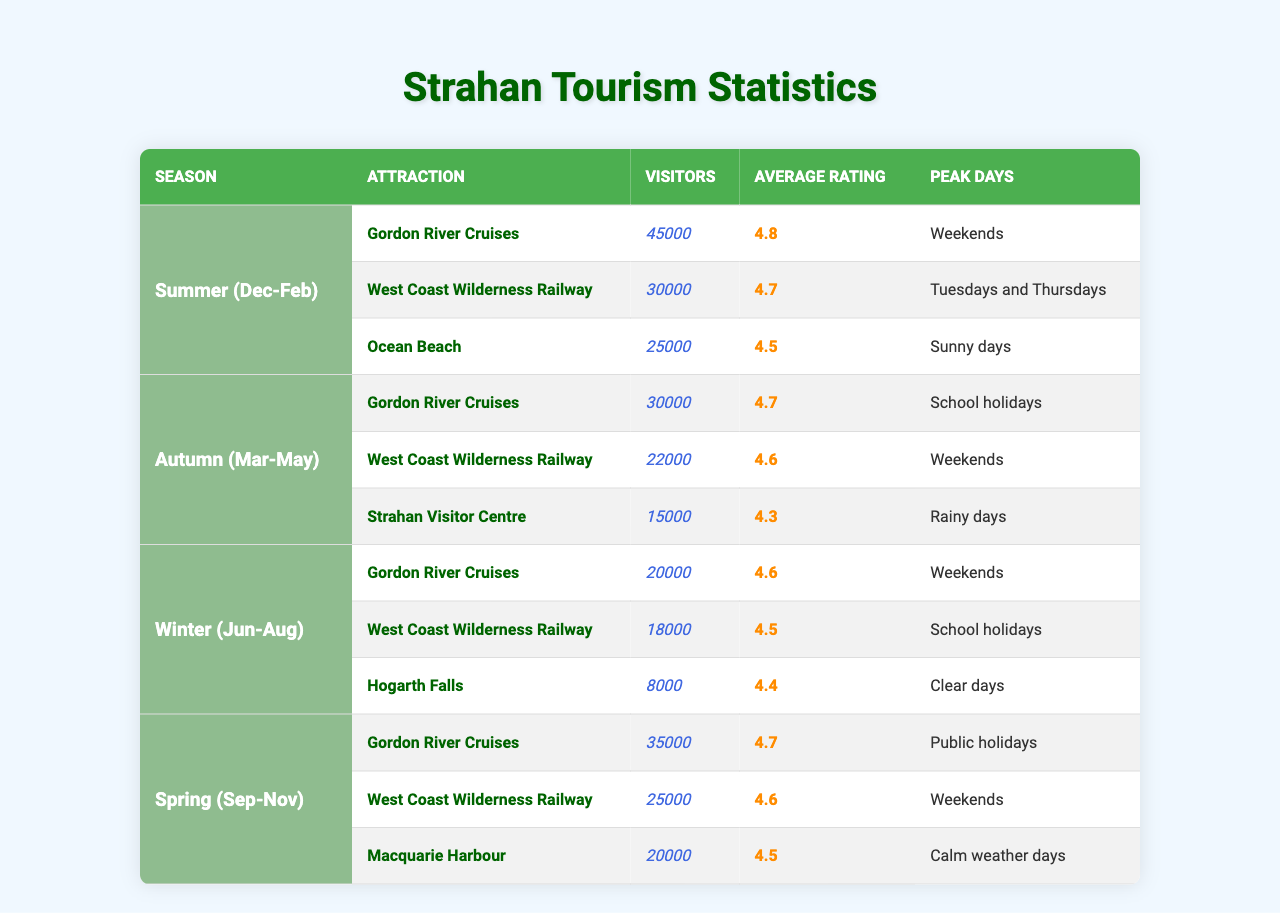What is the average visitor count for Gordon River Cruises across all seasons? In Summer, it has 45,000 visitors, in Autumn it has 30,000, in Winter it has 20,000, and in Spring it has 35,000. The total is 45,000 + 30,000 + 20,000 + 35,000 = 130,000 visitors. Dividing by 4 seasons gives an average of 130,000 / 4 = 32,500.
Answer: 32,500 During which season does the West Coast Wilderness Railway receive the highest number of visitors? The visitor counts for the West Coast Wilderness Railway are: 30,000 (Summer), 22,000 (Autumn), 18,000 (Winter), and 25,000 (Spring). The highest count is 30,000 in Summer.
Answer: Summer Is the average rating of Hogarth Falls higher than that of the Strahan Visitor Centre? Hogarth Falls has an average rating of 4.4 and the Strahan Visitor Centre has an average rating of 4.3. Since 4.4 is higher than 4.3, the statement is true.
Answer: Yes What is the total number of visitors to all attractions in Spring? The total visitors for Spring attractions are: 35,000 (Gordon River Cruises), 25,000 (West Coast Wilderness Railway), and 20,000 (Macquarie Harbour). Adding these gives 35,000 + 25,000 + 20,000 = 80,000 visitors in Spring.
Answer: 80,000 Which season has the fewest total visitors across all attractions? The total visitors are calculated as follows: Summer (45,000 + 30,000 + 25,000 = 100,000), Autumn (30,000 + 22,000 + 15,000 = 67,000), Winter (20,000 + 18,000 + 8,000 = 46,000), Spring (35,000 + 25,000 + 20,000 = 80,000). Winter has the fewest with 46,000 visitors.
Answer: Winter Are weekends the peak days for the most attractions in Summer? In Summer, the peak days are: Gordon River Cruises (Weekends), West Coast Wilderness Railway (Tuesdays and Thursdays), and Ocean Beach (Sunny days). Only one attraction has weekends as peak days.
Answer: No What is the difference in visitors between the busiest and least busy attraction in Winter? The busiest attraction in Winter is Gordon River Cruises with 20,000 visitors and the least busy is Hogarth Falls with 8,000 visitors. The difference is 20,000 - 8,000 = 12,000 visitors.
Answer: 12,000 In which season do visitors enjoy the highest average ratings for attractions? The average ratings for each season are: Summer (4.8, 4.7, 4.5), Autumn (4.7, 4.6, 4.3), Winter (4.6, 4.5, 4.4), and Spring (4.7, 4.6, 4.5). The highest average rating in Summer is 4.8.
Answer: Summer 